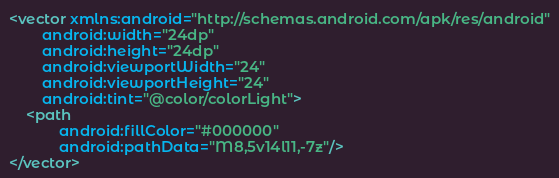Convert code to text. <code><loc_0><loc_0><loc_500><loc_500><_XML_><vector xmlns:android="http://schemas.android.com/apk/res/android"
        android:width="24dp"
        android:height="24dp"
        android:viewportWidth="24"
        android:viewportHeight="24"
        android:tint="@color/colorLight">
    <path
            android:fillColor="#000000"
            android:pathData="M8,5v14l11,-7z"/>
</vector>
</code> 